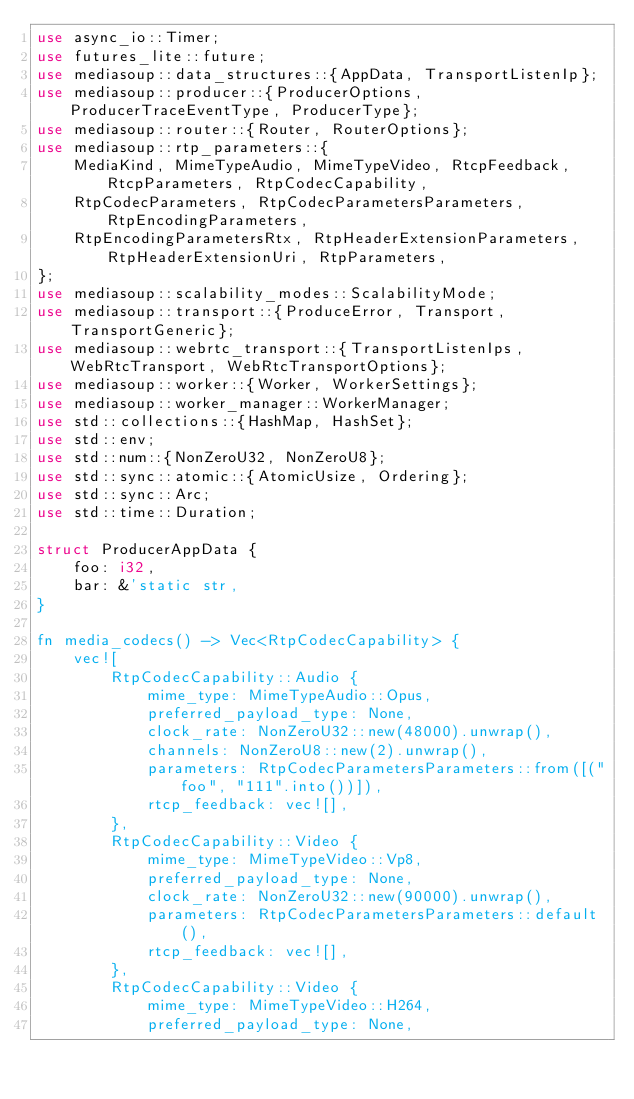Convert code to text. <code><loc_0><loc_0><loc_500><loc_500><_Rust_>use async_io::Timer;
use futures_lite::future;
use mediasoup::data_structures::{AppData, TransportListenIp};
use mediasoup::producer::{ProducerOptions, ProducerTraceEventType, ProducerType};
use mediasoup::router::{Router, RouterOptions};
use mediasoup::rtp_parameters::{
    MediaKind, MimeTypeAudio, MimeTypeVideo, RtcpFeedback, RtcpParameters, RtpCodecCapability,
    RtpCodecParameters, RtpCodecParametersParameters, RtpEncodingParameters,
    RtpEncodingParametersRtx, RtpHeaderExtensionParameters, RtpHeaderExtensionUri, RtpParameters,
};
use mediasoup::scalability_modes::ScalabilityMode;
use mediasoup::transport::{ProduceError, Transport, TransportGeneric};
use mediasoup::webrtc_transport::{TransportListenIps, WebRtcTransport, WebRtcTransportOptions};
use mediasoup::worker::{Worker, WorkerSettings};
use mediasoup::worker_manager::WorkerManager;
use std::collections::{HashMap, HashSet};
use std::env;
use std::num::{NonZeroU32, NonZeroU8};
use std::sync::atomic::{AtomicUsize, Ordering};
use std::sync::Arc;
use std::time::Duration;

struct ProducerAppData {
    foo: i32,
    bar: &'static str,
}

fn media_codecs() -> Vec<RtpCodecCapability> {
    vec![
        RtpCodecCapability::Audio {
            mime_type: MimeTypeAudio::Opus,
            preferred_payload_type: None,
            clock_rate: NonZeroU32::new(48000).unwrap(),
            channels: NonZeroU8::new(2).unwrap(),
            parameters: RtpCodecParametersParameters::from([("foo", "111".into())]),
            rtcp_feedback: vec![],
        },
        RtpCodecCapability::Video {
            mime_type: MimeTypeVideo::Vp8,
            preferred_payload_type: None,
            clock_rate: NonZeroU32::new(90000).unwrap(),
            parameters: RtpCodecParametersParameters::default(),
            rtcp_feedback: vec![],
        },
        RtpCodecCapability::Video {
            mime_type: MimeTypeVideo::H264,
            preferred_payload_type: None,</code> 